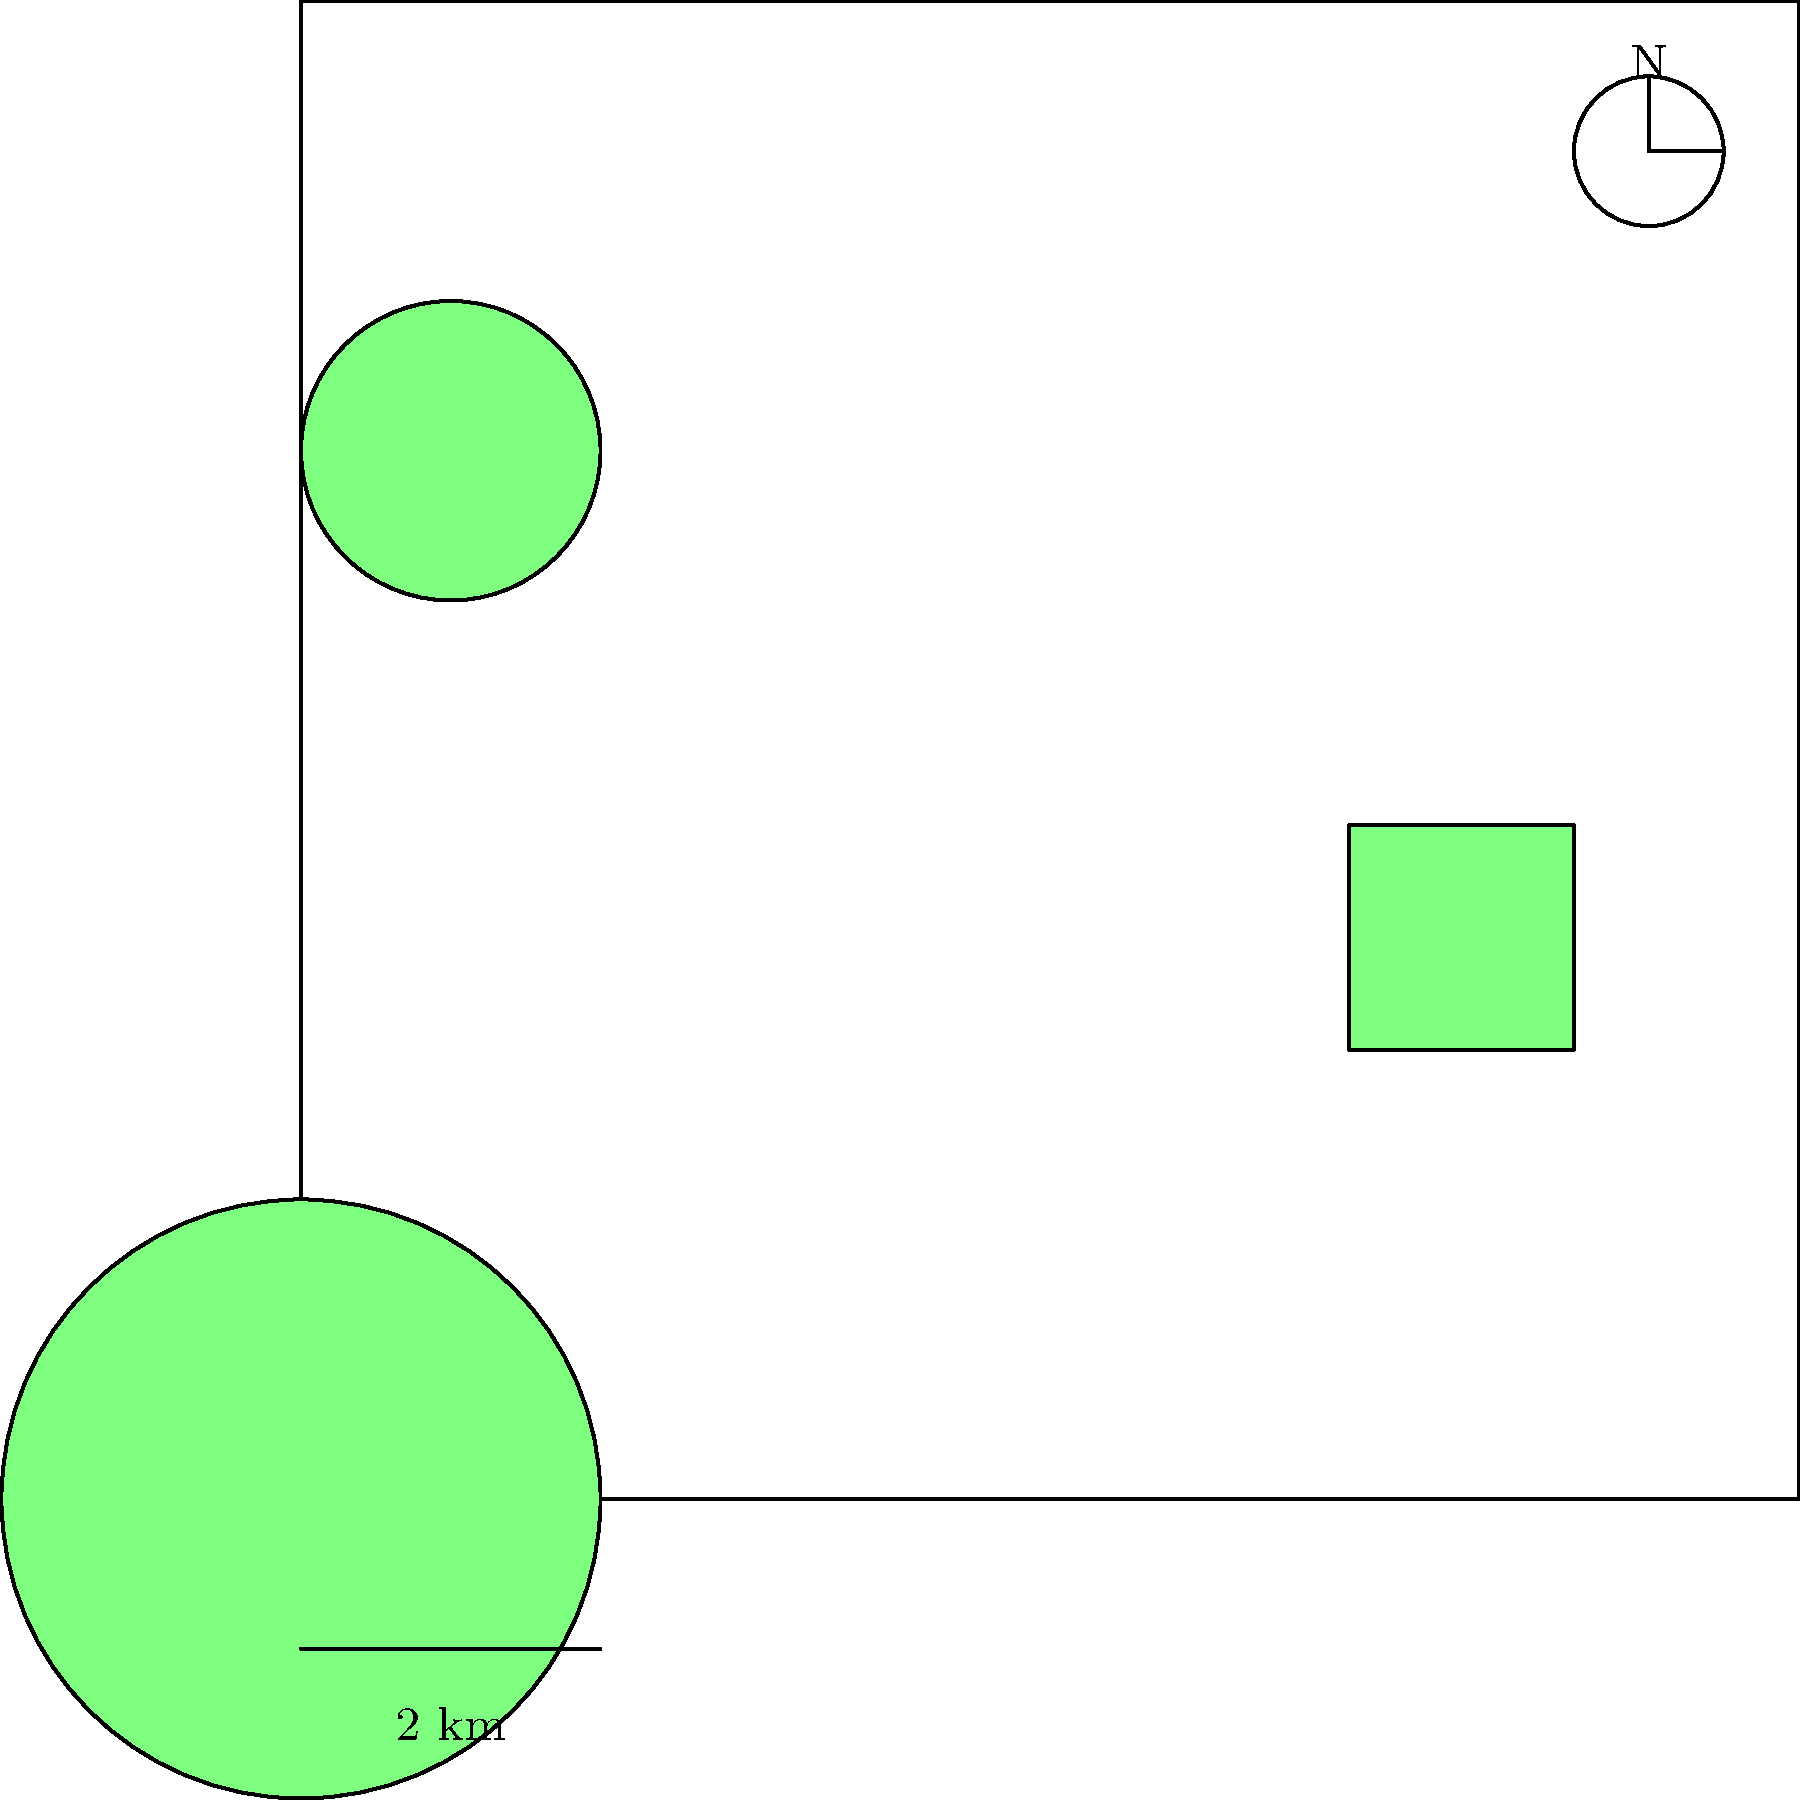Based on the satellite imagery provided, estimate the total protected area in square kilometers. The image shows three distinct protected zones: a large circular area, a square area, and a smaller circular area. Use the scale provided to make your calculation. To estimate the total protected area, we need to calculate the area of each zone and sum them up:

1. Large circular area:
   - Diameter is approximately 4 km
   - Radius (r) = 2 km
   - Area = $\pi r^2 = \pi (2)^2 = 4\pi \approx 12.57$ km²

2. Square area:
   - Side length is approximately 3 km
   - Area = $3 \times 3 = 9$ km²

3. Smaller circular area:
   - Diameter is approximately 2 km
   - Radius (r) = 1 km
   - Area = $\pi r^2 = \pi (1)^2 = \pi \approx 3.14$ km²

Total estimated protected area:
$12.57 + 9 + 3.14 = 24.71$ km²

Rounding to the nearest whole number: 25 km²
Answer: 25 km² 